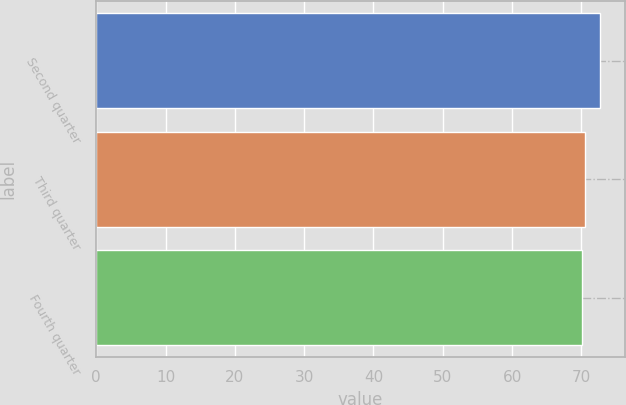Convert chart to OTSL. <chart><loc_0><loc_0><loc_500><loc_500><bar_chart><fcel>Second quarter<fcel>Third quarter<fcel>Fourth quarter<nl><fcel>72.65<fcel>70.44<fcel>70.11<nl></chart> 